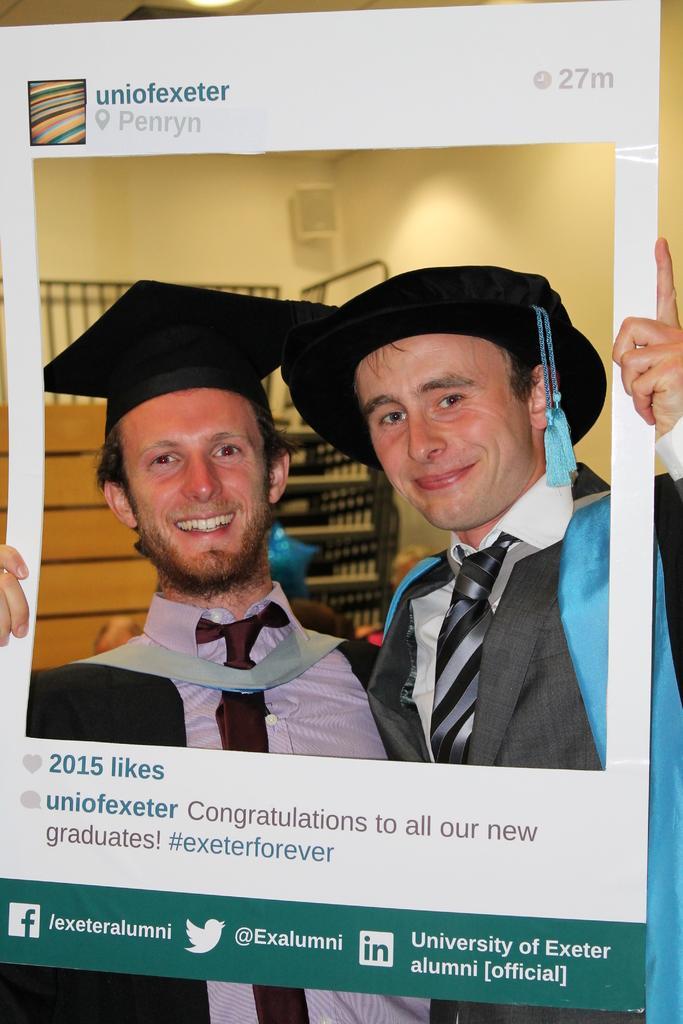Describe this image in one or two sentences. In this picture we can see two men, they wore caps, and they are holding a placard, in the background we can see few racks. 